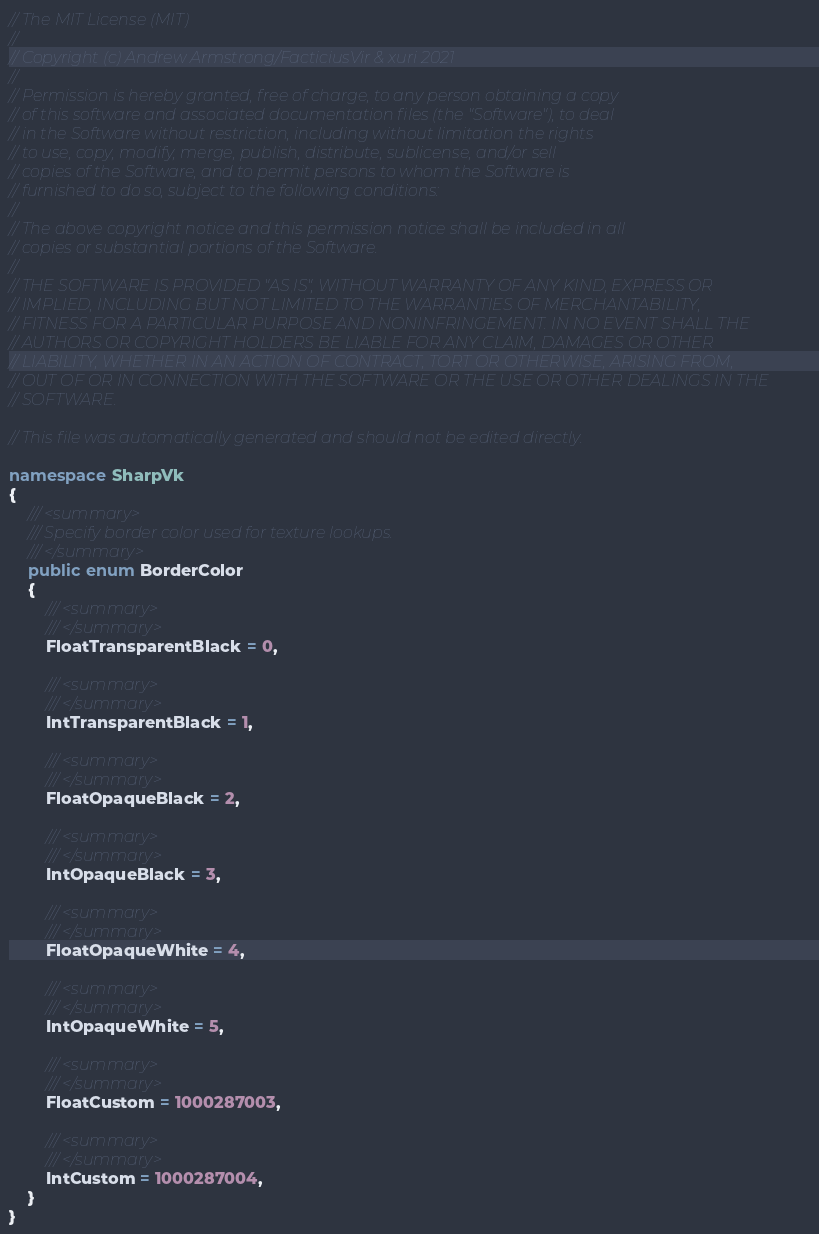<code> <loc_0><loc_0><loc_500><loc_500><_C#_>// The MIT License (MIT)
// 
// Copyright (c) Andrew Armstrong/FacticiusVir & xuri 2021
// 
// Permission is hereby granted, free of charge, to any person obtaining a copy
// of this software and associated documentation files (the "Software"), to deal
// in the Software without restriction, including without limitation the rights
// to use, copy, modify, merge, publish, distribute, sublicense, and/or sell
// copies of the Software, and to permit persons to whom the Software is
// furnished to do so, subject to the following conditions:
// 
// The above copyright notice and this permission notice shall be included in all
// copies or substantial portions of the Software.
// 
// THE SOFTWARE IS PROVIDED "AS IS", WITHOUT WARRANTY OF ANY KIND, EXPRESS OR
// IMPLIED, INCLUDING BUT NOT LIMITED TO THE WARRANTIES OF MERCHANTABILITY,
// FITNESS FOR A PARTICULAR PURPOSE AND NONINFRINGEMENT. IN NO EVENT SHALL THE
// AUTHORS OR COPYRIGHT HOLDERS BE LIABLE FOR ANY CLAIM, DAMAGES OR OTHER
// LIABILITY, WHETHER IN AN ACTION OF CONTRACT, TORT OR OTHERWISE, ARISING FROM,
// OUT OF OR IN CONNECTION WITH THE SOFTWARE OR THE USE OR OTHER DEALINGS IN THE
// SOFTWARE.

// This file was automatically generated and should not be edited directly.

namespace SharpVk
{
    /// <summary>
    /// Specify border color used for texture lookups.
    /// </summary>
    public enum BorderColor
    {
        /// <summary>
        /// </summary>
        FloatTransparentBlack = 0, 
        
        /// <summary>
        /// </summary>
        IntTransparentBlack = 1, 
        
        /// <summary>
        /// </summary>
        FloatOpaqueBlack = 2, 
        
        /// <summary>
        /// </summary>
        IntOpaqueBlack = 3, 
        
        /// <summary>
        /// </summary>
        FloatOpaqueWhite = 4, 
        
        /// <summary>
        /// </summary>
        IntOpaqueWhite = 5, 
        
        /// <summary>
        /// </summary>
        FloatCustom = 1000287003, 
        
        /// <summary>
        /// </summary>
        IntCustom = 1000287004, 
    }
}
</code> 